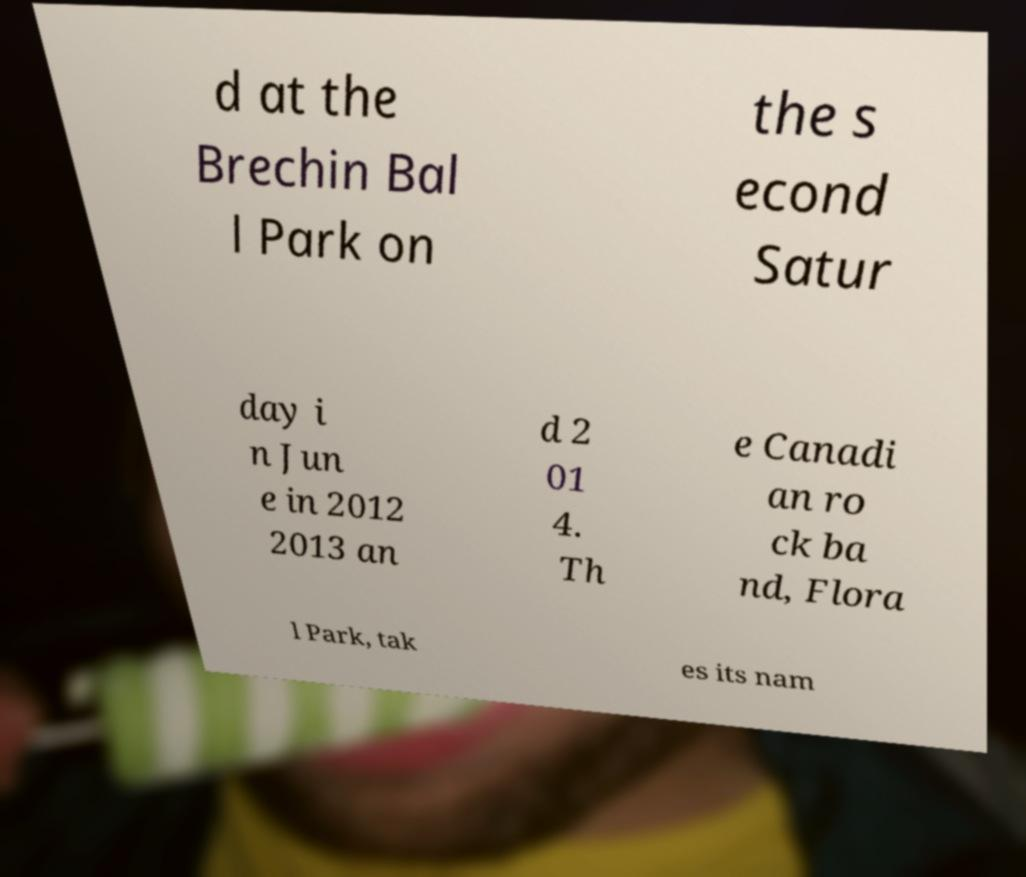I need the written content from this picture converted into text. Can you do that? d at the Brechin Bal l Park on the s econd Satur day i n Jun e in 2012 2013 an d 2 01 4. Th e Canadi an ro ck ba nd, Flora l Park, tak es its nam 